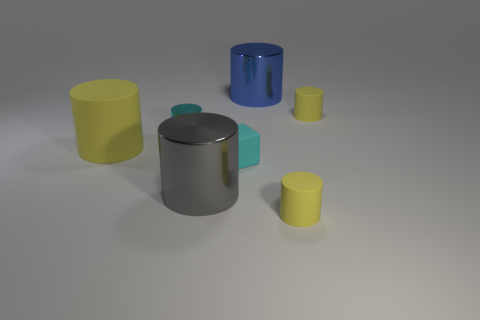Subtract all red blocks. How many yellow cylinders are left? 3 Subtract all big yellow matte cylinders. How many cylinders are left? 5 Subtract 1 cylinders. How many cylinders are left? 5 Subtract all gray cylinders. How many cylinders are left? 5 Subtract all purple cylinders. Subtract all brown balls. How many cylinders are left? 6 Add 1 blue metal blocks. How many objects exist? 8 Subtract all cylinders. How many objects are left? 1 Subtract all big purple blocks. Subtract all large yellow cylinders. How many objects are left? 6 Add 5 tiny rubber things. How many tiny rubber things are left? 8 Add 2 tiny cyan cubes. How many tiny cyan cubes exist? 3 